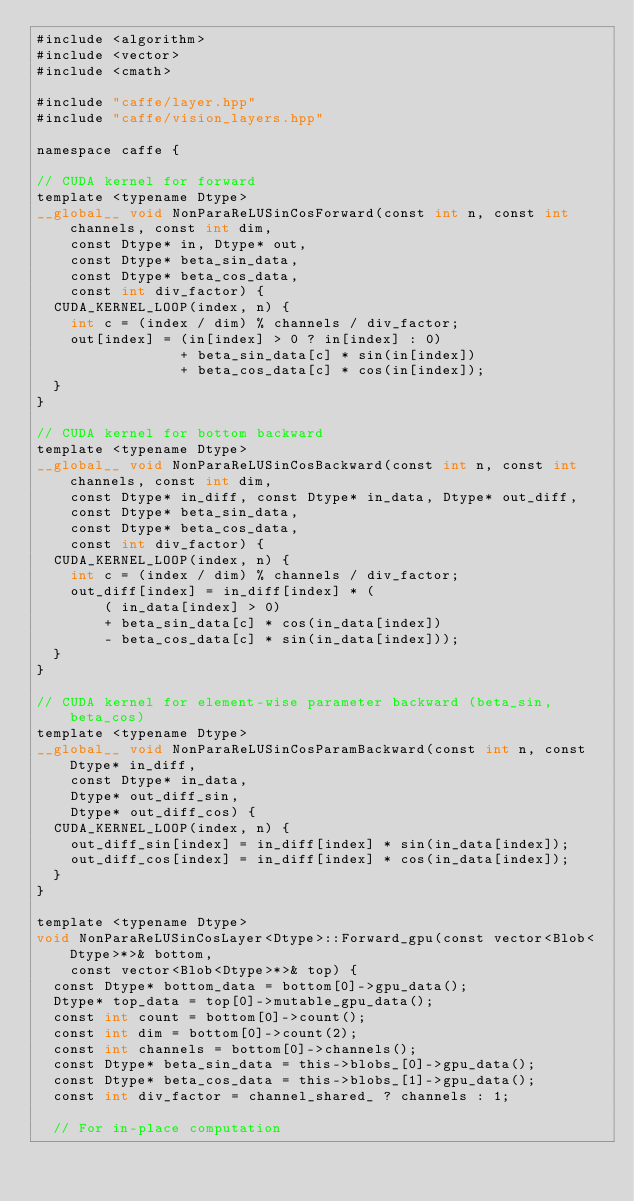Convert code to text. <code><loc_0><loc_0><loc_500><loc_500><_Cuda_>#include <algorithm>
#include <vector>
#include <cmath>

#include "caffe/layer.hpp"
#include "caffe/vision_layers.hpp"

namespace caffe {

// CUDA kernel for forward
template <typename Dtype>
__global__ void NonParaReLUSinCosForward(const int n, const int channels, const int dim,
    const Dtype* in, Dtype* out, 
    const Dtype* beta_sin_data,
    const Dtype* beta_cos_data,
    const int div_factor) {
  CUDA_KERNEL_LOOP(index, n) {
    int c = (index / dim) % channels / div_factor;
    out[index] = (in[index] > 0 ? in[index] : 0)
                 + beta_sin_data[c] * sin(in[index])
                 + beta_cos_data[c] * cos(in[index]);
  }
}

// CUDA kernel for bottom backward
template <typename Dtype>
__global__ void NonParaReLUSinCosBackward(const int n, const int channels, const int dim,
    const Dtype* in_diff, const Dtype* in_data, Dtype* out_diff,
    const Dtype* beta_sin_data,
    const Dtype* beta_cos_data,
    const int div_factor) {
  CUDA_KERNEL_LOOP(index, n) {
    int c = (index / dim) % channels / div_factor;
    out_diff[index] = in_diff[index] * (
        ( in_data[index] > 0)
        + beta_sin_data[c] * cos(in_data[index])
        - beta_cos_data[c] * sin(in_data[index]));
  }
}

// CUDA kernel for element-wise parameter backward (beta_sin, beta_cos)
template <typename Dtype>
__global__ void NonParaReLUSinCosParamBackward(const int n, const Dtype* in_diff,
    const Dtype* in_data,
    Dtype* out_diff_sin,
    Dtype* out_diff_cos) {
  CUDA_KERNEL_LOOP(index, n) {
    out_diff_sin[index] = in_diff[index] * sin(in_data[index]);
    out_diff_cos[index] = in_diff[index] * cos(in_data[index]);
  }
}

template <typename Dtype>
void NonParaReLUSinCosLayer<Dtype>::Forward_gpu(const vector<Blob<Dtype>*>& bottom,
    const vector<Blob<Dtype>*>& top) {
  const Dtype* bottom_data = bottom[0]->gpu_data();
  Dtype* top_data = top[0]->mutable_gpu_data();
  const int count = bottom[0]->count();
  const int dim = bottom[0]->count(2);
  const int channels = bottom[0]->channels();
  const Dtype* beta_sin_data = this->blobs_[0]->gpu_data();
  const Dtype* beta_cos_data = this->blobs_[1]->gpu_data();
  const int div_factor = channel_shared_ ? channels : 1;

  // For in-place computation</code> 